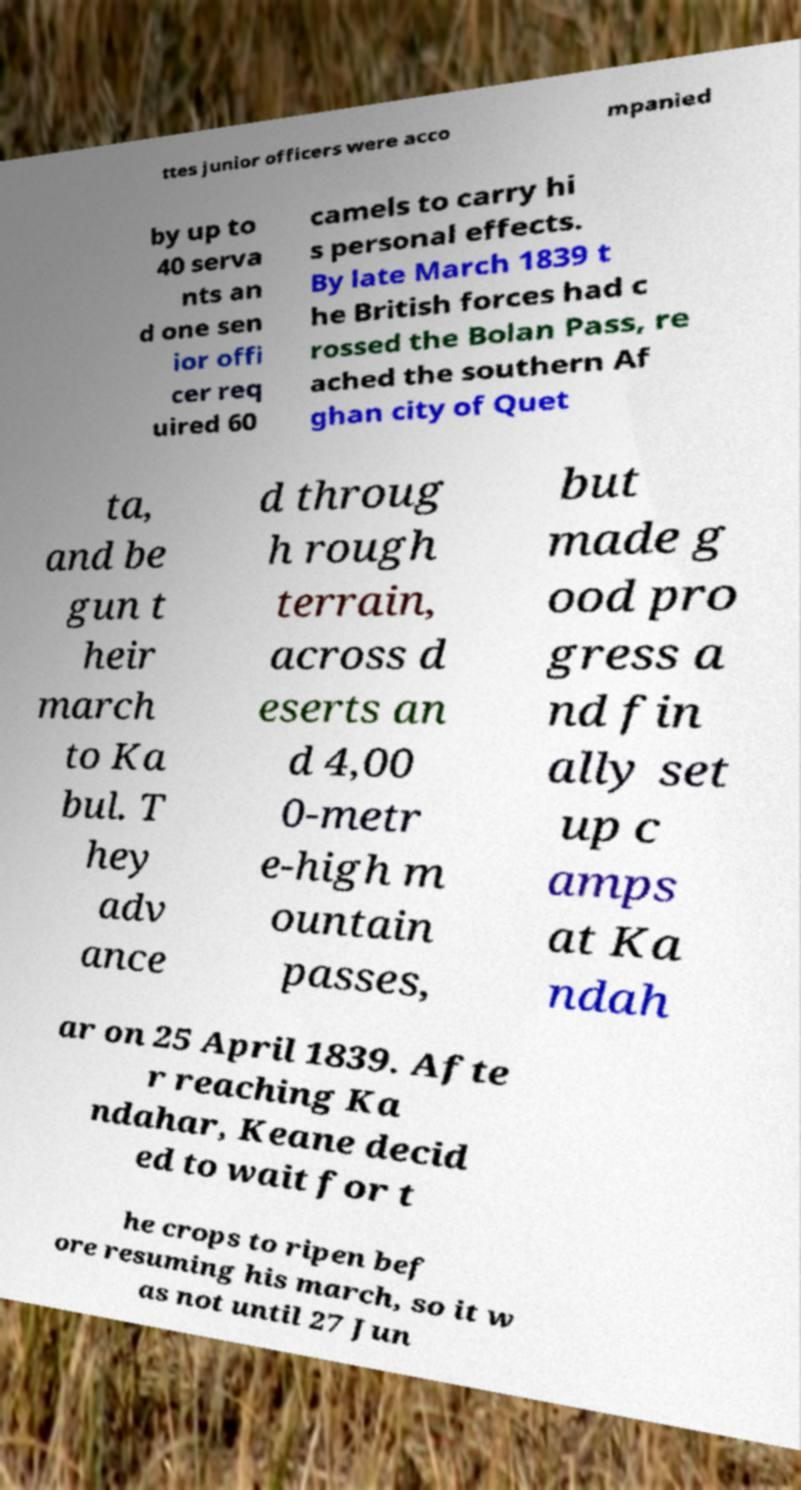Can you accurately transcribe the text from the provided image for me? ttes junior officers were acco mpanied by up to 40 serva nts an d one sen ior offi cer req uired 60 camels to carry hi s personal effects. By late March 1839 t he British forces had c rossed the Bolan Pass, re ached the southern Af ghan city of Quet ta, and be gun t heir march to Ka bul. T hey adv ance d throug h rough terrain, across d eserts an d 4,00 0-metr e-high m ountain passes, but made g ood pro gress a nd fin ally set up c amps at Ka ndah ar on 25 April 1839. Afte r reaching Ka ndahar, Keane decid ed to wait for t he crops to ripen bef ore resuming his march, so it w as not until 27 Jun 